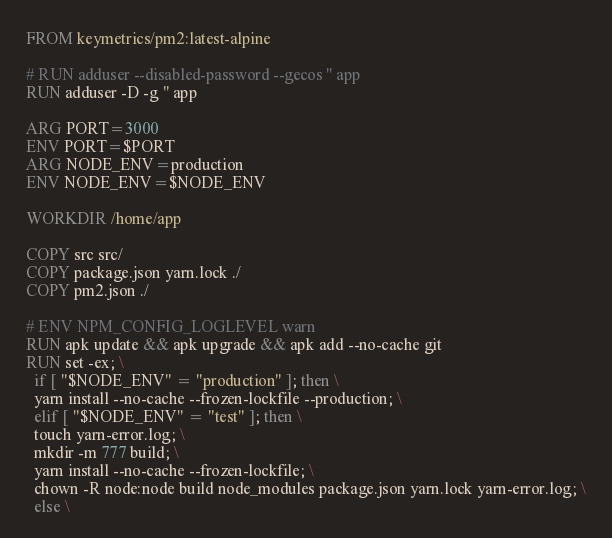Convert code to text. <code><loc_0><loc_0><loc_500><loc_500><_Dockerfile_>FROM keymetrics/pm2:latest-alpine

# RUN adduser --disabled-password --gecos '' app
RUN adduser -D -g '' app

ARG PORT=3000
ENV PORT=$PORT
ARG NODE_ENV=production
ENV NODE_ENV=$NODE_ENV

WORKDIR /home/app

COPY src src/
COPY package.json yarn.lock ./
COPY pm2.json ./

# ENV NPM_CONFIG_LOGLEVEL warn
RUN apk update && apk upgrade && apk add --no-cache git
RUN set -ex; \
  if [ "$NODE_ENV" = "production" ]; then \
  yarn install --no-cache --frozen-lockfile --production; \
  elif [ "$NODE_ENV" = "test" ]; then \
  touch yarn-error.log; \
  mkdir -m 777 build; \
  yarn install --no-cache --frozen-lockfile; \
  chown -R node:node build node_modules package.json yarn.lock yarn-error.log; \
  else \</code> 